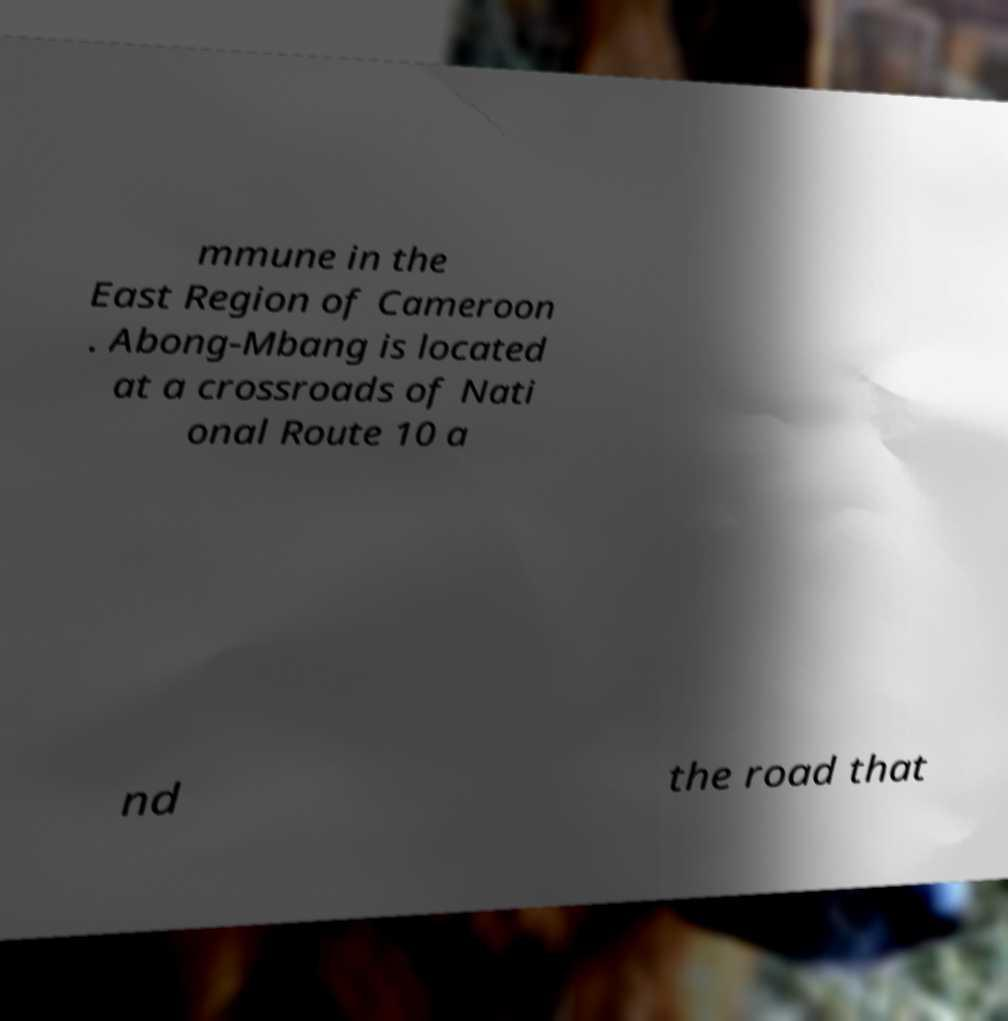Please read and relay the text visible in this image. What does it say? mmune in the East Region of Cameroon . Abong-Mbang is located at a crossroads of Nati onal Route 10 a nd the road that 